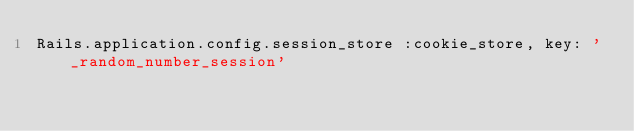<code> <loc_0><loc_0><loc_500><loc_500><_Ruby_>Rails.application.config.session_store :cookie_store, key: '_random_number_session'
</code> 